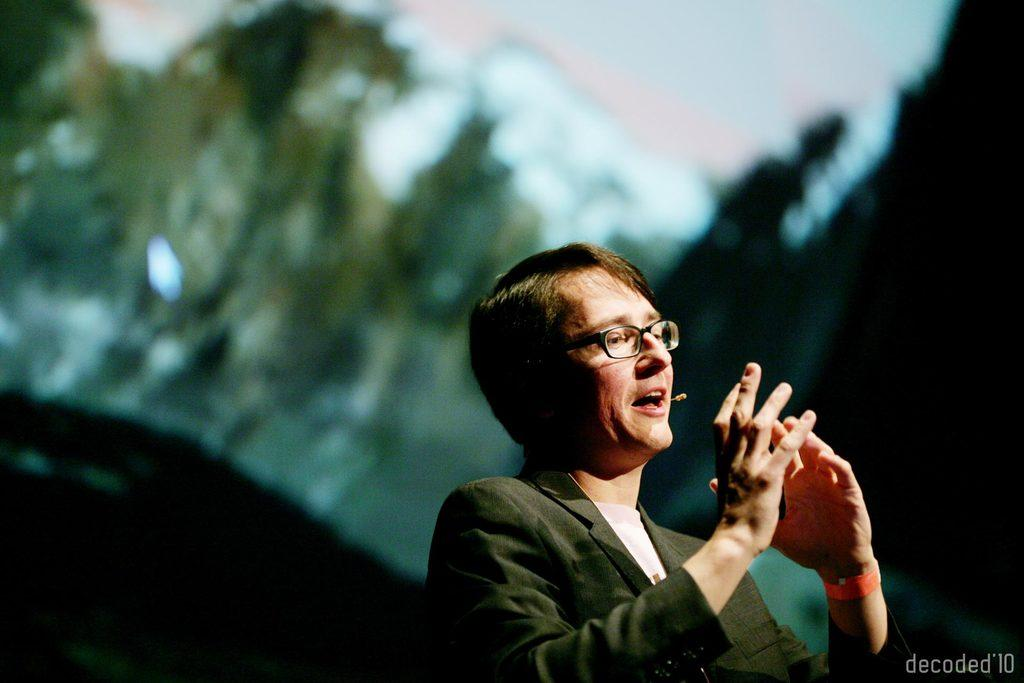What can be found in the bottom right corner of the image? There is a watermark in the bottom right corner of the image. What is the person in the image wearing? The person is wearing a suit and a spectacle. What is the person in the image doing? The person is speaking. How would you describe the background of the image? The background of the image is blurred. What type of pest can be seen crawling on the person's suit in the image? There are no pests visible in the image; the person is wearing a suit and a spectacle while speaking. What type of drink is the person holding in the image? There is no drink present in the image; the person is speaking and wearing a suit and a spectacle. 